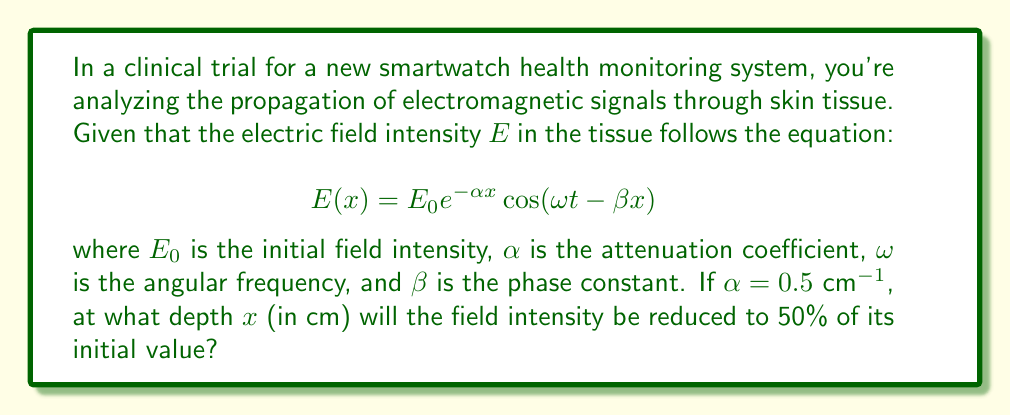Solve this math problem. To solve this problem, we'll follow these steps:

1) The amplitude of the electric field at any depth $x$ is given by $E_0 e^{-\alpha x}$.

2) We want to find $x$ where the amplitude is 50% of the initial value. This can be expressed as:

   $$E_0 e^{-\alpha x} = 0.5E_0$$

3) Dividing both sides by $E_0$:

   $$e^{-\alpha x} = 0.5$$

4) Taking the natural logarithm of both sides:

   $$-\alpha x = \ln(0.5)$$

5) Solving for $x$:

   $$x = -\frac{\ln(0.5)}{\alpha}$$

6) We know that $\alpha = 0.5 \text{ cm}^{-1}$. Substituting this value:

   $$x = -\frac{\ln(0.5)}{0.5 \text{ cm}^{-1}}$$

7) Evaluating:

   $$x \approx 1.3863 \text{ cm}$$

Therefore, the field intensity will be reduced to 50% of its initial value at a depth of approximately 1.3863 cm.
Answer: 1.3863 cm 